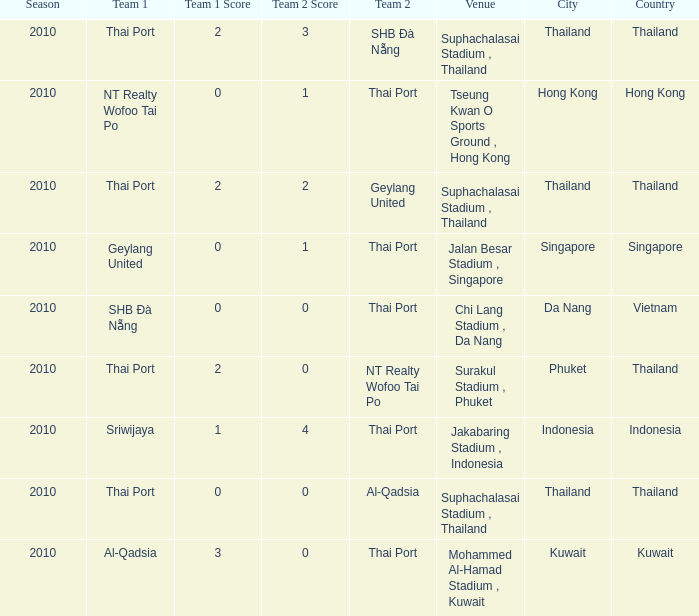Could you help me parse every detail presented in this table? {'header': ['Season', 'Team 1', 'Team 1 Score', 'Team 2 Score', 'Team 2', 'Venue', 'City', 'Country'], 'rows': [['2010', 'Thai Port', '2', '3', 'SHB Ðà Nẵng', 'Suphachalasai Stadium , Thailand', 'Thailand', 'Thailand'], ['2010', 'NT Realty Wofoo Tai Po', '0', '1', 'Thai Port', 'Tseung Kwan O Sports Ground , Hong Kong', 'Hong Kong', 'Hong Kong'], ['2010', 'Thai Port', '2', '2', 'Geylang United', 'Suphachalasai Stadium , Thailand', 'Thailand', 'Thailand'], ['2010', 'Geylang United', '0', '1', 'Thai Port', 'Jalan Besar Stadium , Singapore', 'Singapore', 'Singapore'], ['2010', 'SHB Ðà Nẵng', '0', '0', 'Thai Port', 'Chi Lang Stadium , Da Nang', 'Da Nang', 'Vietnam'], ['2010', 'Thai Port', '2', '0', 'NT Realty Wofoo Tai Po', 'Surakul Stadium , Phuket', 'Phuket', 'Thailand'], ['2010', 'Sriwijaya', '1', '4', 'Thai Port', 'Jakabaring Stadium , Indonesia', 'Indonesia', 'Indonesia'], ['2010', 'Thai Port', '0', '0', 'Al-Qadsia', 'Suphachalasai Stadium , Thailand', 'Thailand', 'Thailand'], ['2010', 'Al-Qadsia', '3', '0', 'Thai Port', 'Mohammed Al-Hamad Stadium , Kuwait', 'Kuwait', 'Kuwait']]} What was the score for the game in which Al-Qadsia was Team 2? 0:0. 